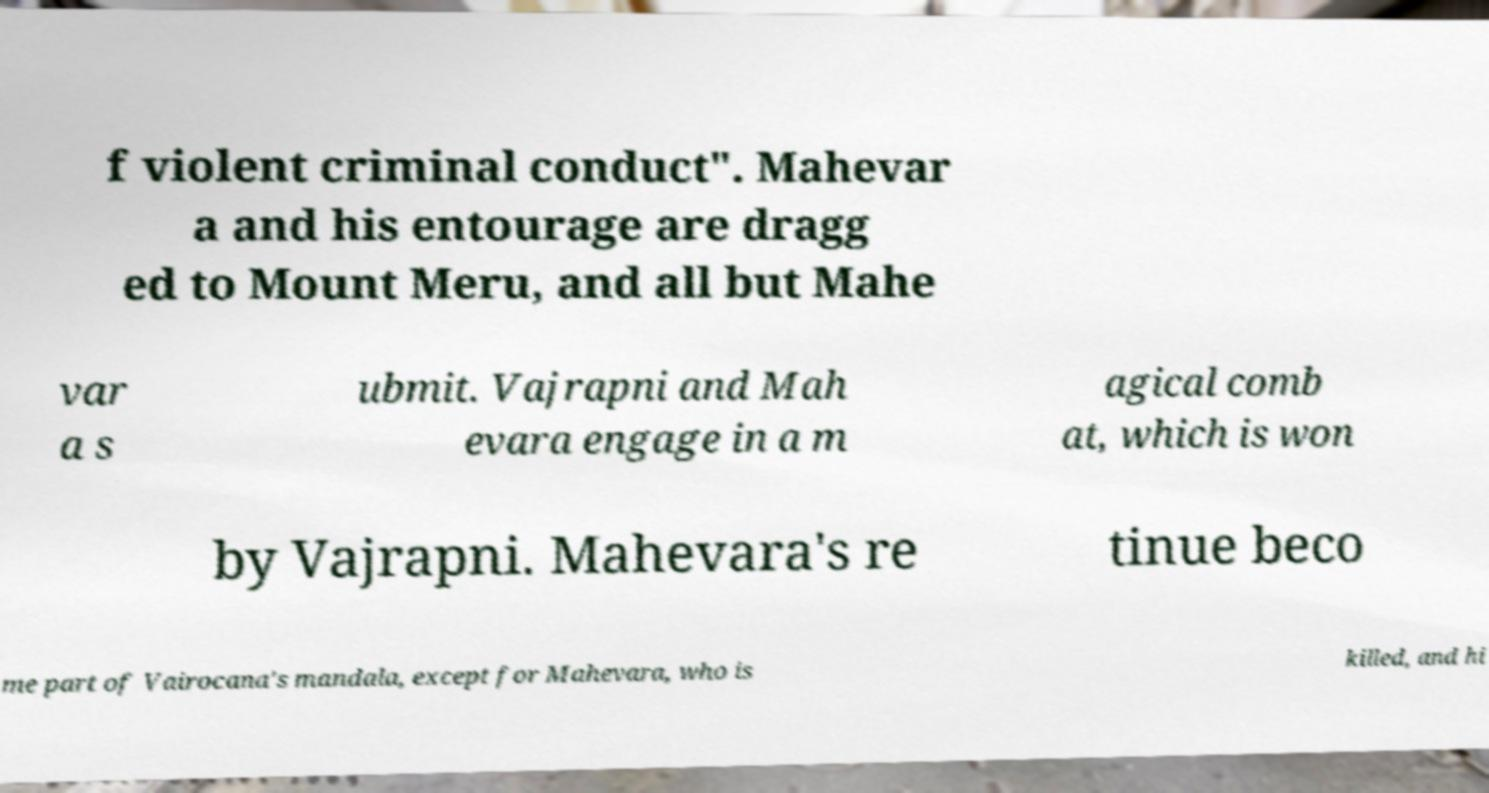There's text embedded in this image that I need extracted. Can you transcribe it verbatim? f violent criminal conduct". Mahevar a and his entourage are dragg ed to Mount Meru, and all but Mahe var a s ubmit. Vajrapni and Mah evara engage in a m agical comb at, which is won by Vajrapni. Mahevara's re tinue beco me part of Vairocana's mandala, except for Mahevara, who is killed, and hi 